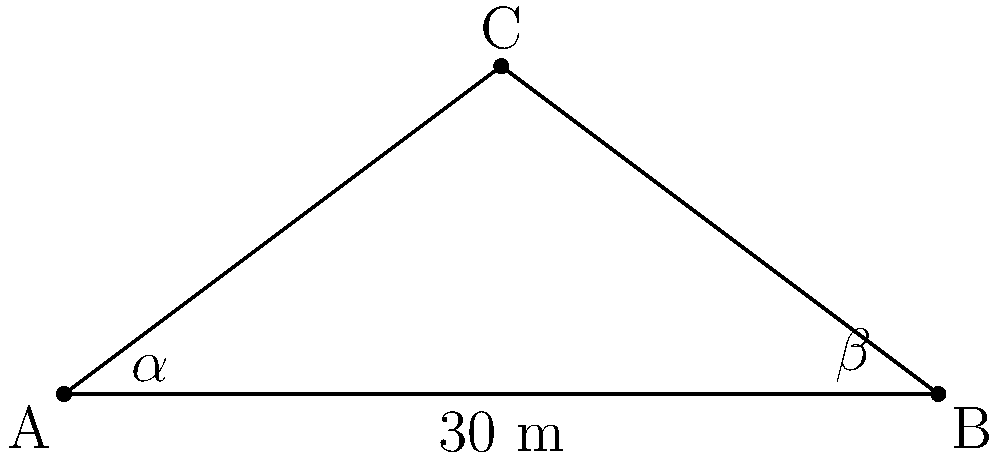You are surveying a ruined tower on an ancient battlefield. From point A, the angle of elevation to the top of the tower (point C) is $\alpha = 40°$. You move 30 meters to point B, where the angle of elevation to the top of the tower is $\beta = 35°$. What is the height of the tower? Let's solve this step-by-step:

1) We can use the tangent function to set up two equations:
   
   $\tan(\alpha) = \frac{h}{x}$ and $\tan(\beta) = \frac{h}{30-x}$

   where $h$ is the height of the tower and $x$ is the distance from point A to the base of the tower.

2) We can equate these:

   $x \tan(\beta) = (30-x) \tan(\alpha)$

3) Expanding:

   $x \tan(\beta) = 30 \tan(\alpha) - x \tan(\alpha)$

4) Rearranging:

   $x(\tan(\beta) + \tan(\alpha)) = 30 \tan(\alpha)$

5) Solving for $x$:

   $x = \frac{30 \tan(\alpha)}{\tan(\beta) + \tan(\alpha)}$

6) Plugging in the values:

   $x = \frac{30 \tan(40°)}{\tan(35°) + \tan(40°)} \approx 16.63$ meters

7) Now we can find the height using either of our original equations. Let's use the first one:

   $h = x \tan(\alpha) = 16.63 \tan(40°) \approx 13.95$ meters

Therefore, the height of the tower is approximately 13.95 meters.
Answer: 13.95 meters 